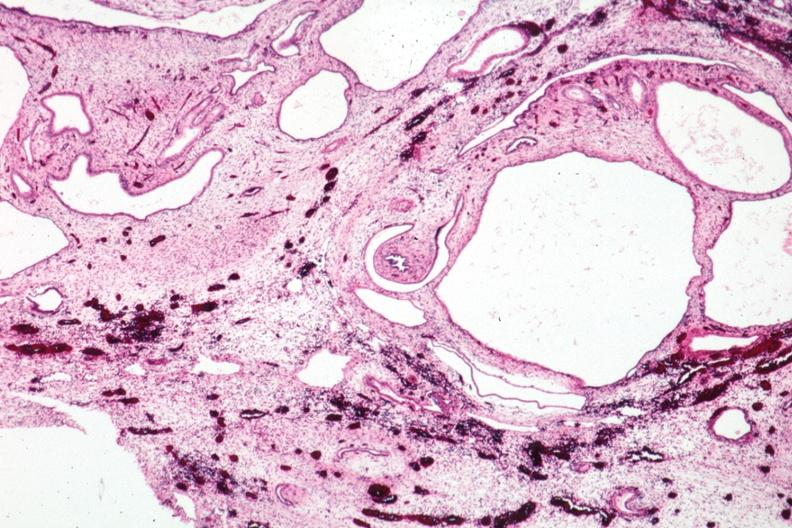where is this?
Answer the question using a single word or phrase. Urinary 